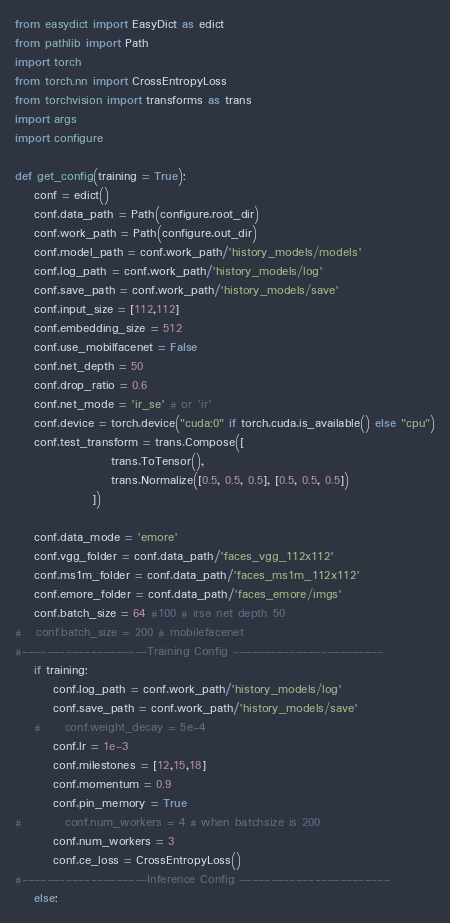Convert code to text. <code><loc_0><loc_0><loc_500><loc_500><_Python_>from easydict import EasyDict as edict
from pathlib import Path
import torch
from torch.nn import CrossEntropyLoss
from torchvision import transforms as trans
import args
import configure

def get_config(training = True):
    conf = edict()
    conf.data_path = Path(configure.root_dir)
    conf.work_path = Path(configure.out_dir)
    conf.model_path = conf.work_path/'history_models/models'
    conf.log_path = conf.work_path/'history_models/log'
    conf.save_path = conf.work_path/'history_models/save'
    conf.input_size = [112,112]
    conf.embedding_size = 512
    conf.use_mobilfacenet = False
    conf.net_depth = 50
    conf.drop_ratio = 0.6
    conf.net_mode = 'ir_se' # or 'ir'
    conf.device = torch.device("cuda:0" if torch.cuda.is_available() else "cpu")
    conf.test_transform = trans.Compose([
                    trans.ToTensor(),
                    trans.Normalize([0.5, 0.5, 0.5], [0.5, 0.5, 0.5])
                ])

    conf.data_mode = 'emore'
    conf.vgg_folder = conf.data_path/'faces_vgg_112x112'
    conf.ms1m_folder = conf.data_path/'faces_ms1m_112x112'
    conf.emore_folder = conf.data_path/'faces_emore/imgs'
    conf.batch_size = 64 #100 # irse net depth 50
#   conf.batch_size = 200 # mobilefacenet
#--------------------Training Config ------------------------
    if training:
        conf.log_path = conf.work_path/'history_models/log'
        conf.save_path = conf.work_path/'history_models/save'
    #     conf.weight_decay = 5e-4
        conf.lr = 1e-3
        conf.milestones = [12,15,18]
        conf.momentum = 0.9
        conf.pin_memory = True
#         conf.num_workers = 4 # when batchsize is 200
        conf.num_workers = 3
        conf.ce_loss = CrossEntropyLoss()
#--------------------Inference Config ------------------------
    else:</code> 